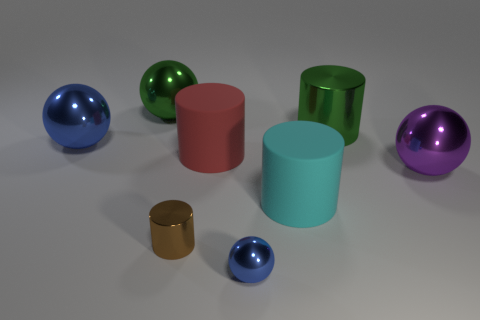Subtract 2 cylinders. How many cylinders are left? 2 Subtract all big spheres. How many spheres are left? 1 Subtract all gray cylinders. Subtract all green balls. How many cylinders are left? 4 Add 1 big green shiny things. How many objects exist? 9 Add 6 purple things. How many purple things are left? 7 Add 7 cyan matte objects. How many cyan matte objects exist? 8 Subtract 1 red cylinders. How many objects are left? 7 Subtract all brown metallic things. Subtract all tiny blue metallic balls. How many objects are left? 6 